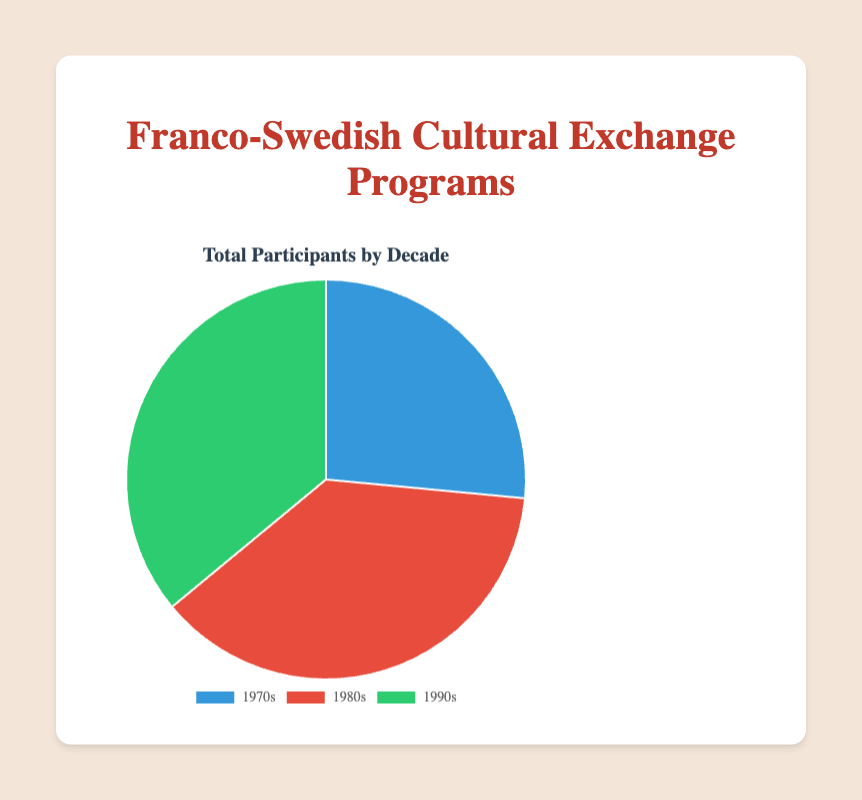Which decade had the highest number of participants in cultural exchange programs? The pie chart shows segments for the 1970s, 1980s, and 1990s. The largest segment corresponds to the 1980s, indicating the highest number of participants.
Answer: 1980s Which decade had the lowest number of participants in cultural exchange programs? The pie chart shows segments for the 1970s, 1980s, and 1990s. The smallest segment corresponds to the 1970s, indicating the lowest number of participants.
Answer: 1970s How many total participants were there in the 1990s? The pie chart shows numerical values on each segment for the decades. The segment labeled '1990s' shows 720 participants.
Answer: 720 What is the total number of participants across all three decades? Sum the participants from each decade: 530 (1970s) + 750 (1980s) + 720 (1990s) = 2000 participants.
Answer: 2000 How many more participants were there in the 1980s compared to the 1970s? Subtract the number of participants in the 1970s from the number in the 1980s: 750 - 530 = 220 participants.
Answer: 220 What percentage of the total participants were in the 1990s? First, find the total number of participants: 530 (1970s) + 750 (1980s) + 720 (1990s) = 2000. Then, calculate the percentage for the 1990s: (720 / 2000) * 100 ≈ 36%.
Answer: 36% Which decade is represented by the green segment? By visually inspecting the pie chart, the green segment corresponds to the 1990s.
Answer: 1990s 